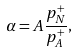Convert formula to latex. <formula><loc_0><loc_0><loc_500><loc_500>\alpha = A \frac { p _ { N } ^ { + } } { p _ { A } ^ { + } } ,</formula> 